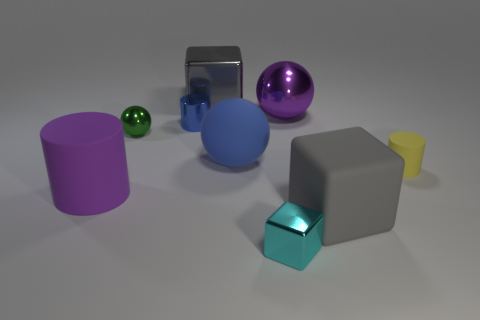If these objects were part of a children's play area, which could be most interesting for a child? Children might be attracted to the large purple transparent sphere due to its size, color, and transparency, or the reflective cube for its shiny surface that can spark curiosity. 